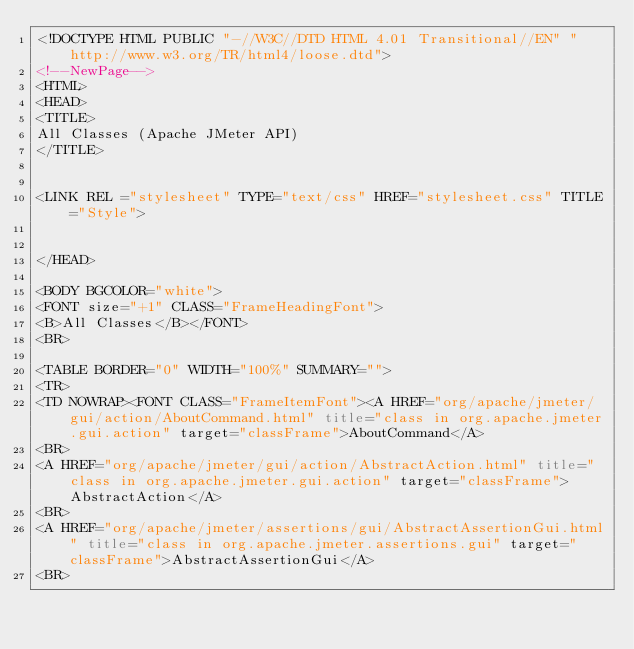Convert code to text. <code><loc_0><loc_0><loc_500><loc_500><_HTML_><!DOCTYPE HTML PUBLIC "-//W3C//DTD HTML 4.01 Transitional//EN" "http://www.w3.org/TR/html4/loose.dtd">
<!--NewPage-->
<HTML>
<HEAD>
<TITLE>
All Classes (Apache JMeter API)
</TITLE>


<LINK REL ="stylesheet" TYPE="text/css" HREF="stylesheet.css" TITLE="Style">


</HEAD>

<BODY BGCOLOR="white">
<FONT size="+1" CLASS="FrameHeadingFont">
<B>All Classes</B></FONT>
<BR>

<TABLE BORDER="0" WIDTH="100%" SUMMARY="">
<TR>
<TD NOWRAP><FONT CLASS="FrameItemFont"><A HREF="org/apache/jmeter/gui/action/AboutCommand.html" title="class in org.apache.jmeter.gui.action" target="classFrame">AboutCommand</A>
<BR>
<A HREF="org/apache/jmeter/gui/action/AbstractAction.html" title="class in org.apache.jmeter.gui.action" target="classFrame">AbstractAction</A>
<BR>
<A HREF="org/apache/jmeter/assertions/gui/AbstractAssertionGui.html" title="class in org.apache.jmeter.assertions.gui" target="classFrame">AbstractAssertionGui</A>
<BR></code> 